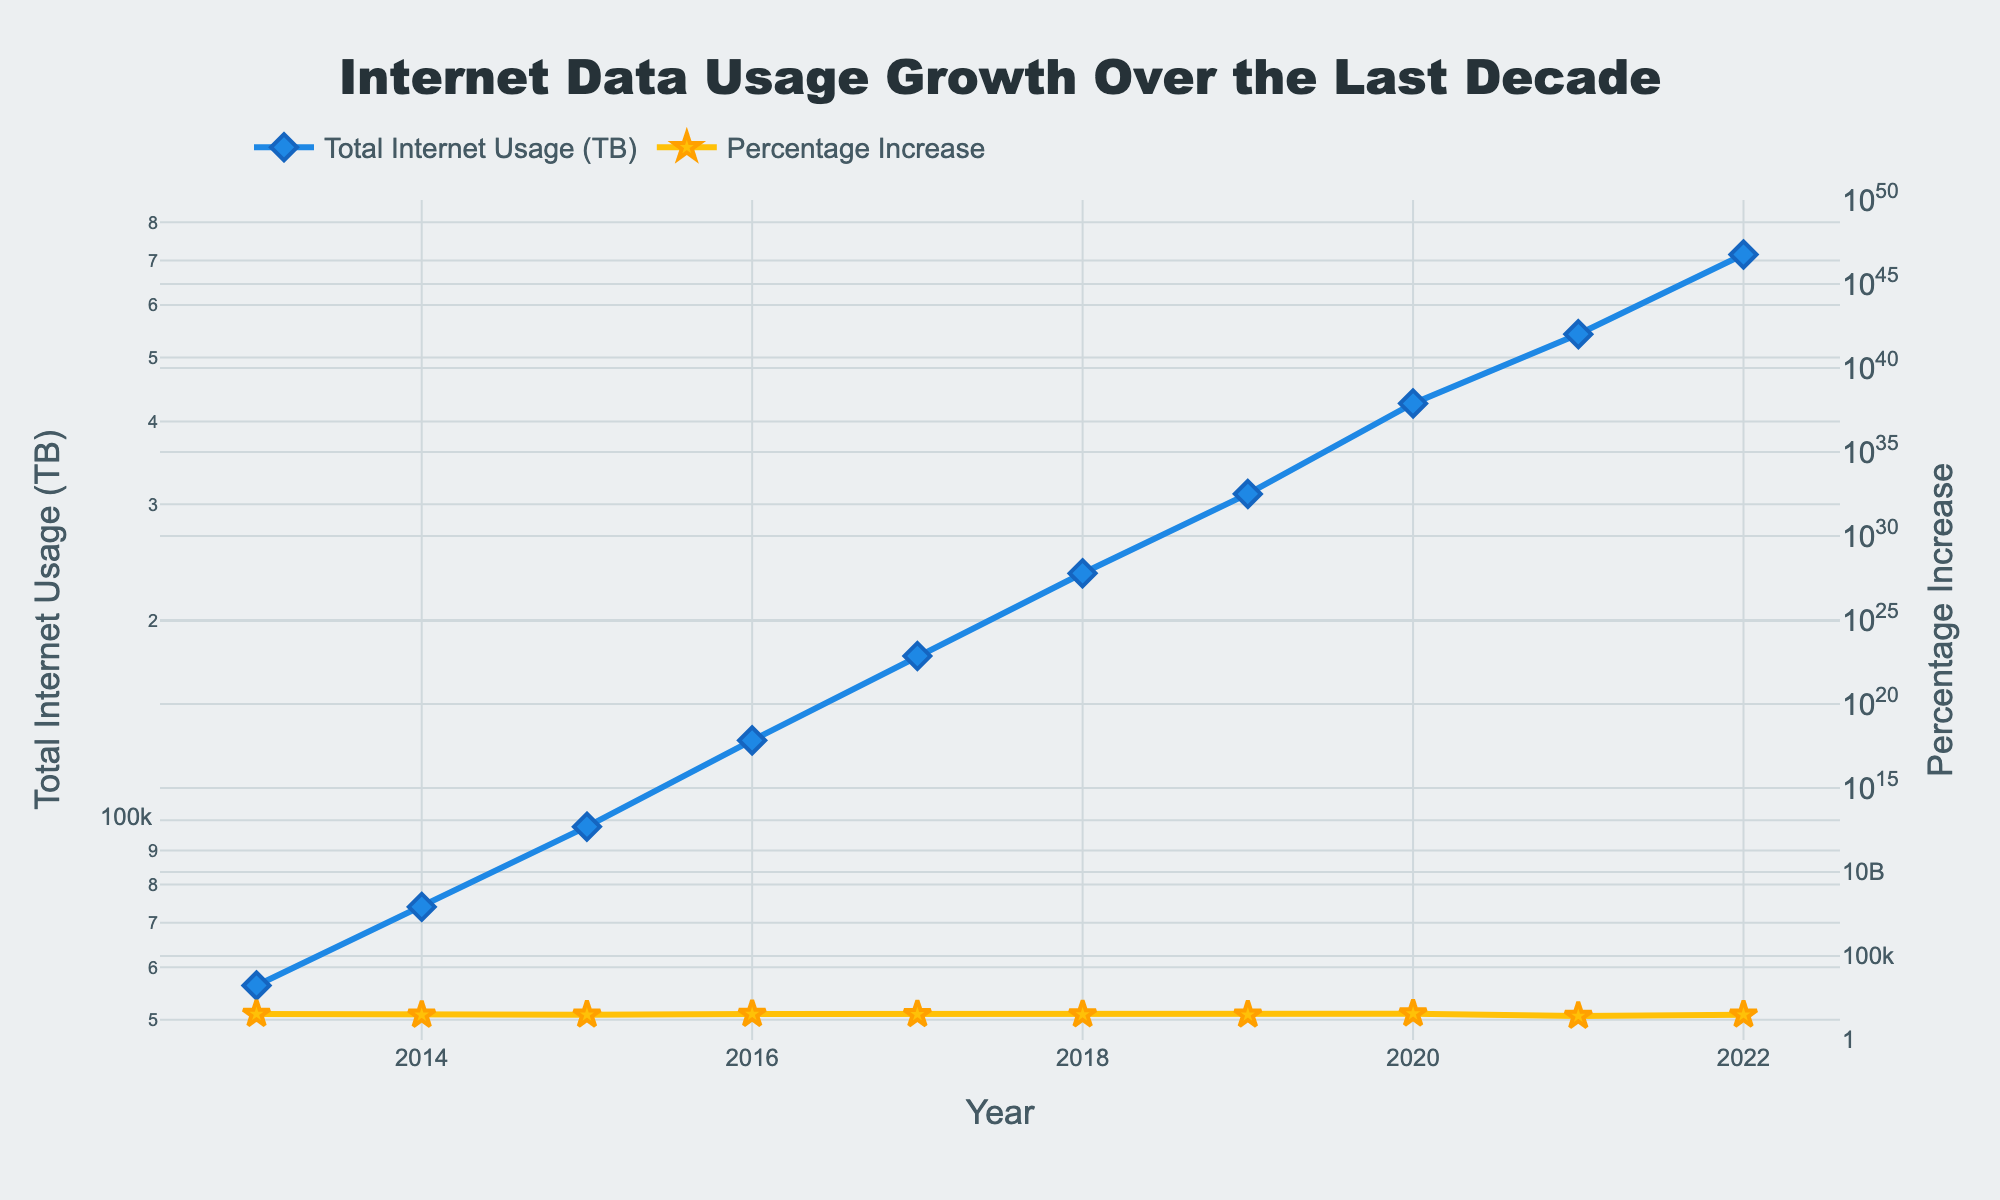What is the title of the plot? The title of the plot is usually displayed at the top of the figure. In this case, it is centered and reads: 'Internet Data Usage Growth Over the Last Decade'.
Answer: Internet Data Usage Growth Over the Last Decade How many data points are there in the plot? To determine the number of data points, count the number of years shown on the x-axis or the markers in the lines. Here, data is shown for each year from 2013 to 2022, so there are 10 data points.
Answer: 10 What is the color of the line representing Total Internet Usage (TB)? The color of the line representing Total Internet Usage (TB) can be identified by looking at the legend beside the respective label. The line color is blue.
Answer: Blue By how much did the Total Internet Usage (TB) increase from 2019 to 2020? To find the increase, subtract the Total Internet Usage for 2019 from that for 2020: 426,000 TB - 311,000 TB = 115,000 TB.
Answer: 115,000 TB In which year was the highest Percentage Increase observed and what was the value? To find the year with the highest Percentage Increase, look for the peak value on the y2-axis. The highest value observed is 37% in the year 2020.
Answer: 2020, 37% What was the trend in Total Internet Usage (TB) from 2013 to 2022? The Total Internet Usage (TB) line shows an overall upward trend from 2013 to 2022, as the values consistently increase each year.
Answer: Upward trend Compare the Percentage Increase in 2014 and 2021. Which year had a higher percentage and by how much? Compare the values for 2014 (31%) and 2021 (27%). The Percentage Increase was higher in 2014. The difference is 31% - 27% = 4%.
Answer: 2014, 4% What is the average Percentage Increase over the entire period? Sum the Percentage Increase values for all years and divide by the number of years: (35 + 31 + 32 + 35 + 34 + 33 + 32 + 37 + 27 + 32) / 10 = 32.8%.
Answer: 32.8% If the Percentage Increase continued at the average rate calculated above, what would be the projected Percentage Increase in 2023? If we assume the Percentage Increase continues at the average rate of 32.8%, then the projected Percentage Increase for 2023 would be 32.8%.
Answer: 32.8% 